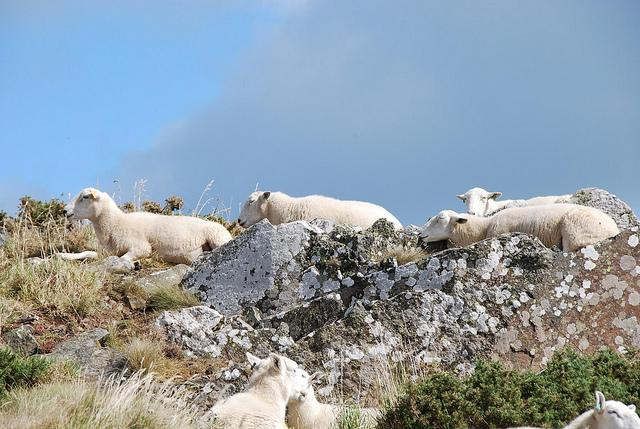What are the animals doing on the hill? resting 